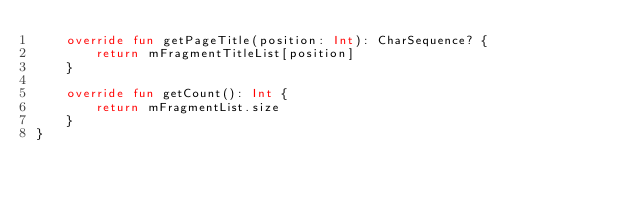Convert code to text. <code><loc_0><loc_0><loc_500><loc_500><_Kotlin_>    override fun getPageTitle(position: Int): CharSequence? {
        return mFragmentTitleList[position]
    }

    override fun getCount(): Int {
        return mFragmentList.size
    }
}</code> 